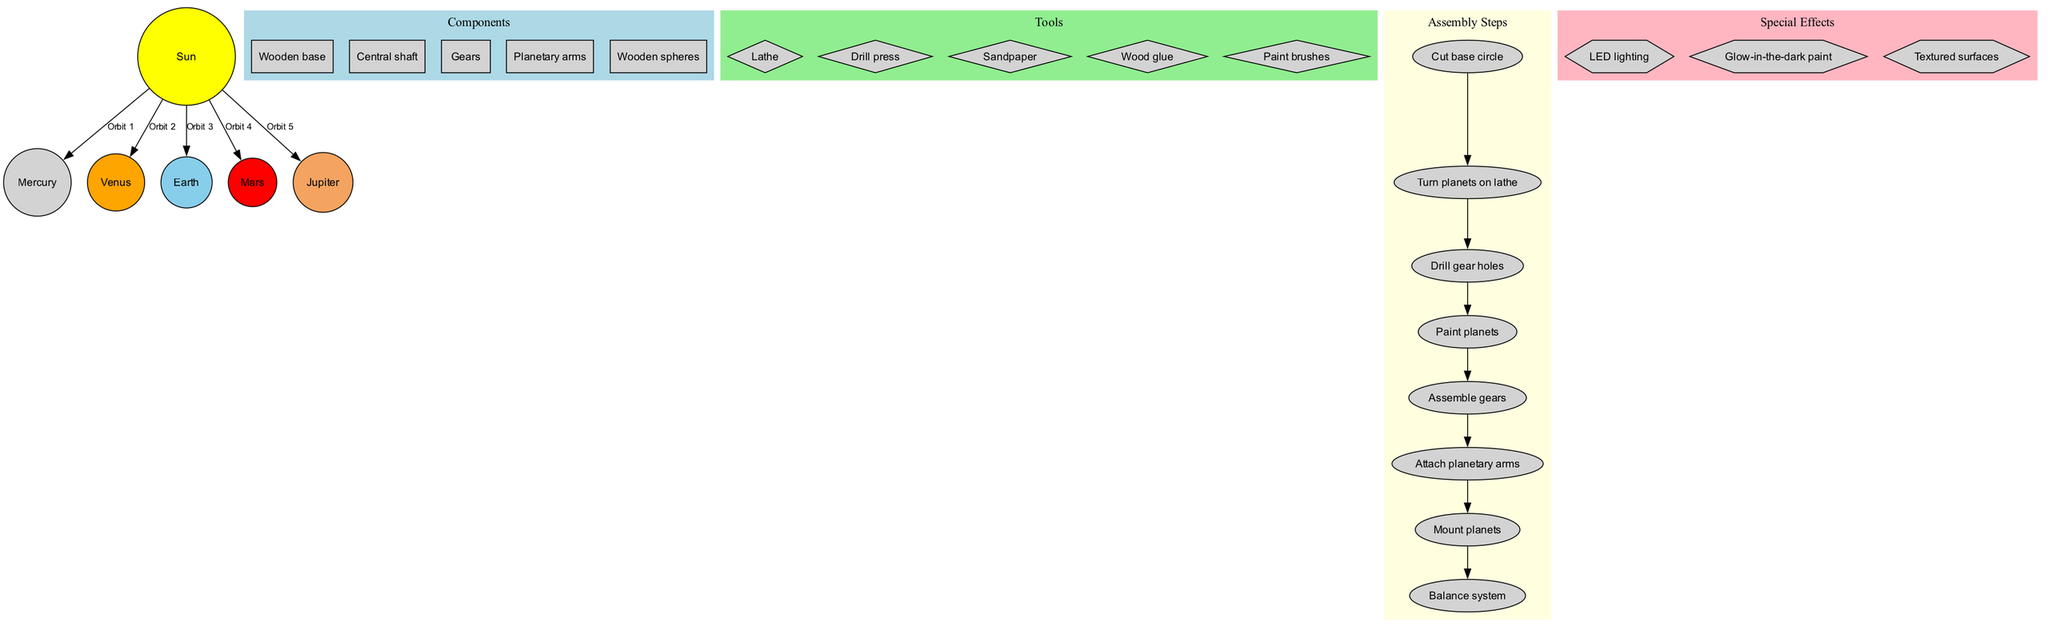What is the centerpiece of the orrery? The diagram clearly shows the Sun highlighted as the centerpiece. It is depicted in yellow at the center of the diagram.
Answer: Sun How many planets are there? The diagram lists five planets connected to the Sun, indicating the total number of planets.
Answer: 5 What color represents Mars? The diagram uses red to depict Mars, which is clearly labeled within the planetary section.
Answer: Red What is the first step in the assembly process? The assembly steps start with "Cut base circle," which is the first node in the assembly steps subgraph.
Answer: Cut base circle Which tool is used for turning planets? The diagram includes a tool labeled "Lathe" that is specific for the task of turning planets.
Answer: Lathe How are the components categorized in the diagram? The components are organized into a distinct cluster labeled 'Components', which distinguishes them from tools and assembly steps.
Answer: Components Which special effect involves lighting? The diagram lists "LED lighting" as one of the special effects, specifying its role in enhancing the orrery.
Answer: LED lighting What is the last assembly step? Examining the sequence of assembly steps, "Balance system" is shown as the final step in the process.
Answer: Balance system Which planet is the largest? Based on general knowledge, the largest planet listed is Jupiter, which can be inferred from its presence in the diagram.
Answer: Jupiter 